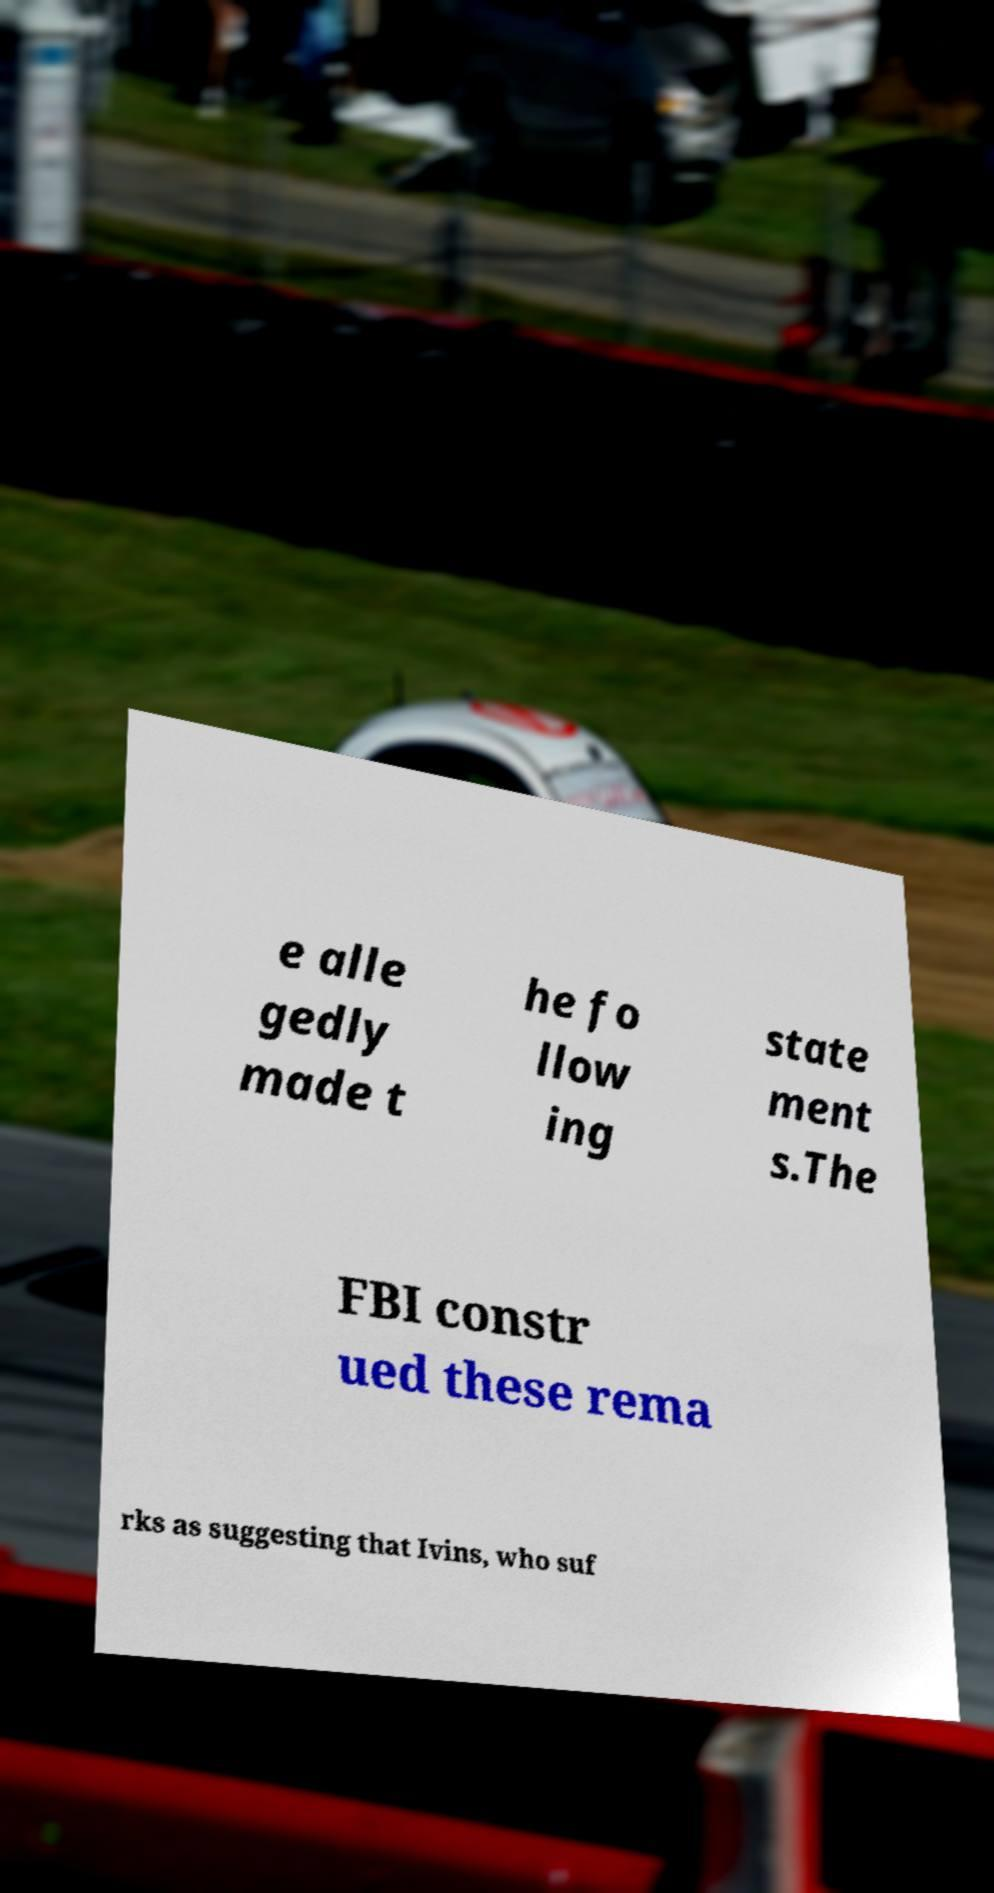Could you extract and type out the text from this image? e alle gedly made t he fo llow ing state ment s.The FBI constr ued these rema rks as suggesting that Ivins, who suf 